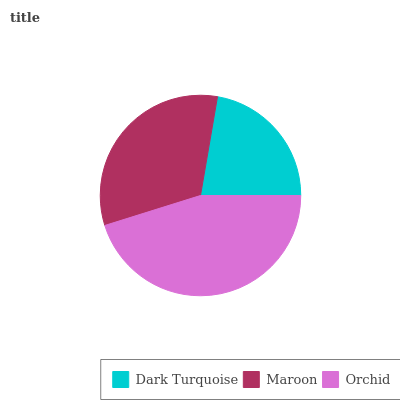Is Dark Turquoise the minimum?
Answer yes or no. Yes. Is Orchid the maximum?
Answer yes or no. Yes. Is Maroon the minimum?
Answer yes or no. No. Is Maroon the maximum?
Answer yes or no. No. Is Maroon greater than Dark Turquoise?
Answer yes or no. Yes. Is Dark Turquoise less than Maroon?
Answer yes or no. Yes. Is Dark Turquoise greater than Maroon?
Answer yes or no. No. Is Maroon less than Dark Turquoise?
Answer yes or no. No. Is Maroon the high median?
Answer yes or no. Yes. Is Maroon the low median?
Answer yes or no. Yes. Is Orchid the high median?
Answer yes or no. No. Is Dark Turquoise the low median?
Answer yes or no. No. 